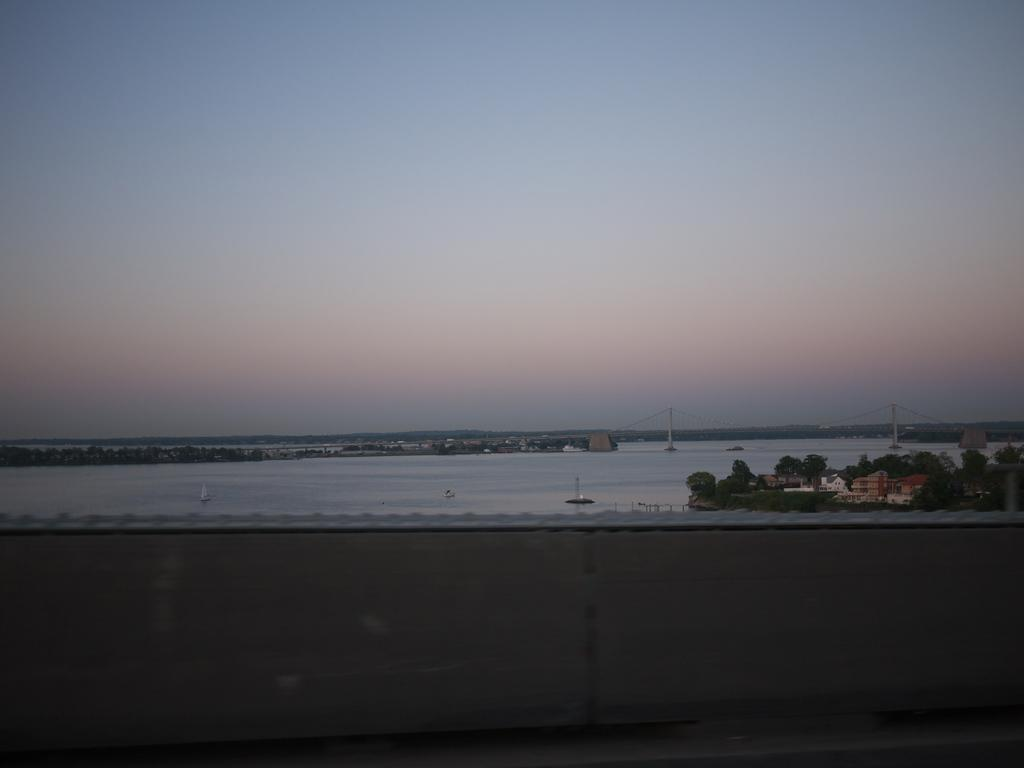What is on the water in the image? There are boats on the water in the image. What type of vegetation can be seen in the image? Trees are visible in the image. What type of structures are present in the image? Houses are present in the image. What is visible in the sky in the image? Clouds are visible in the sky. What type of fruit is hanging from the trees in the image? There is no fruit visible in the image; only trees are present. Can you see any monkeys in the image? There are no monkeys present in the image. 